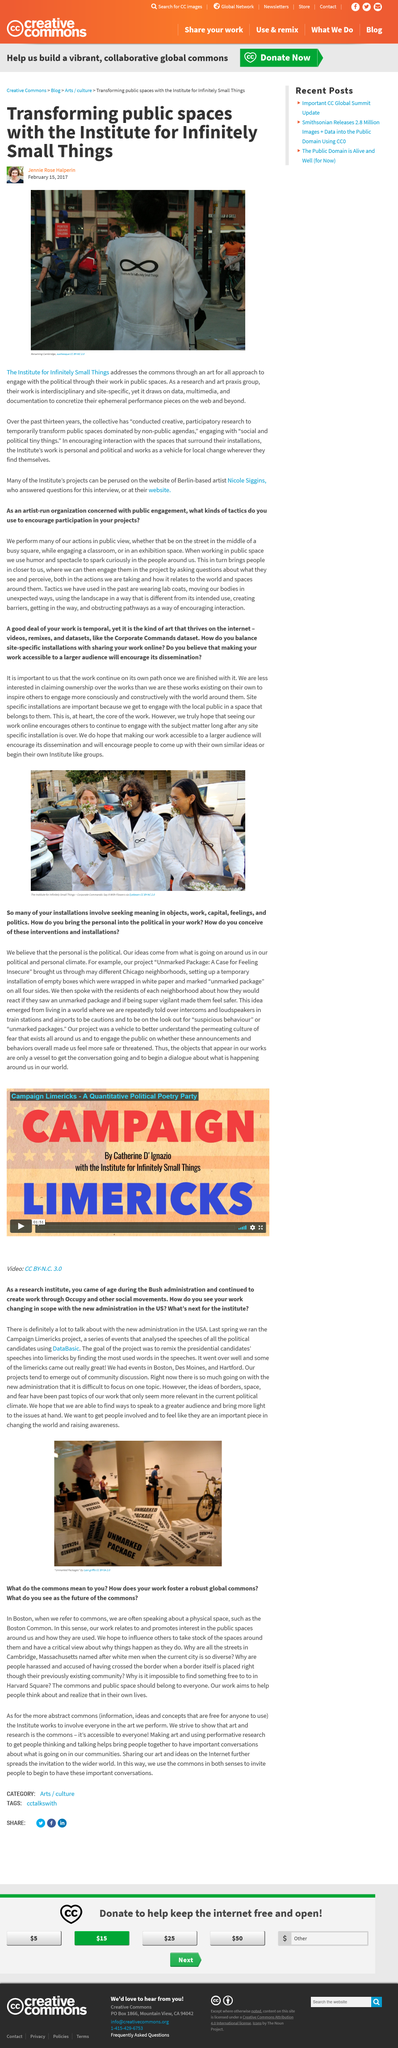Give some essential details in this illustration. The article title is 'Transforming Public Spaces with the Institute for Infinitely Small Things.' The Institute is a research and art praxis group of a particular kind. On February 15th, 2017, Jennie Rose Halperin authored this article. 